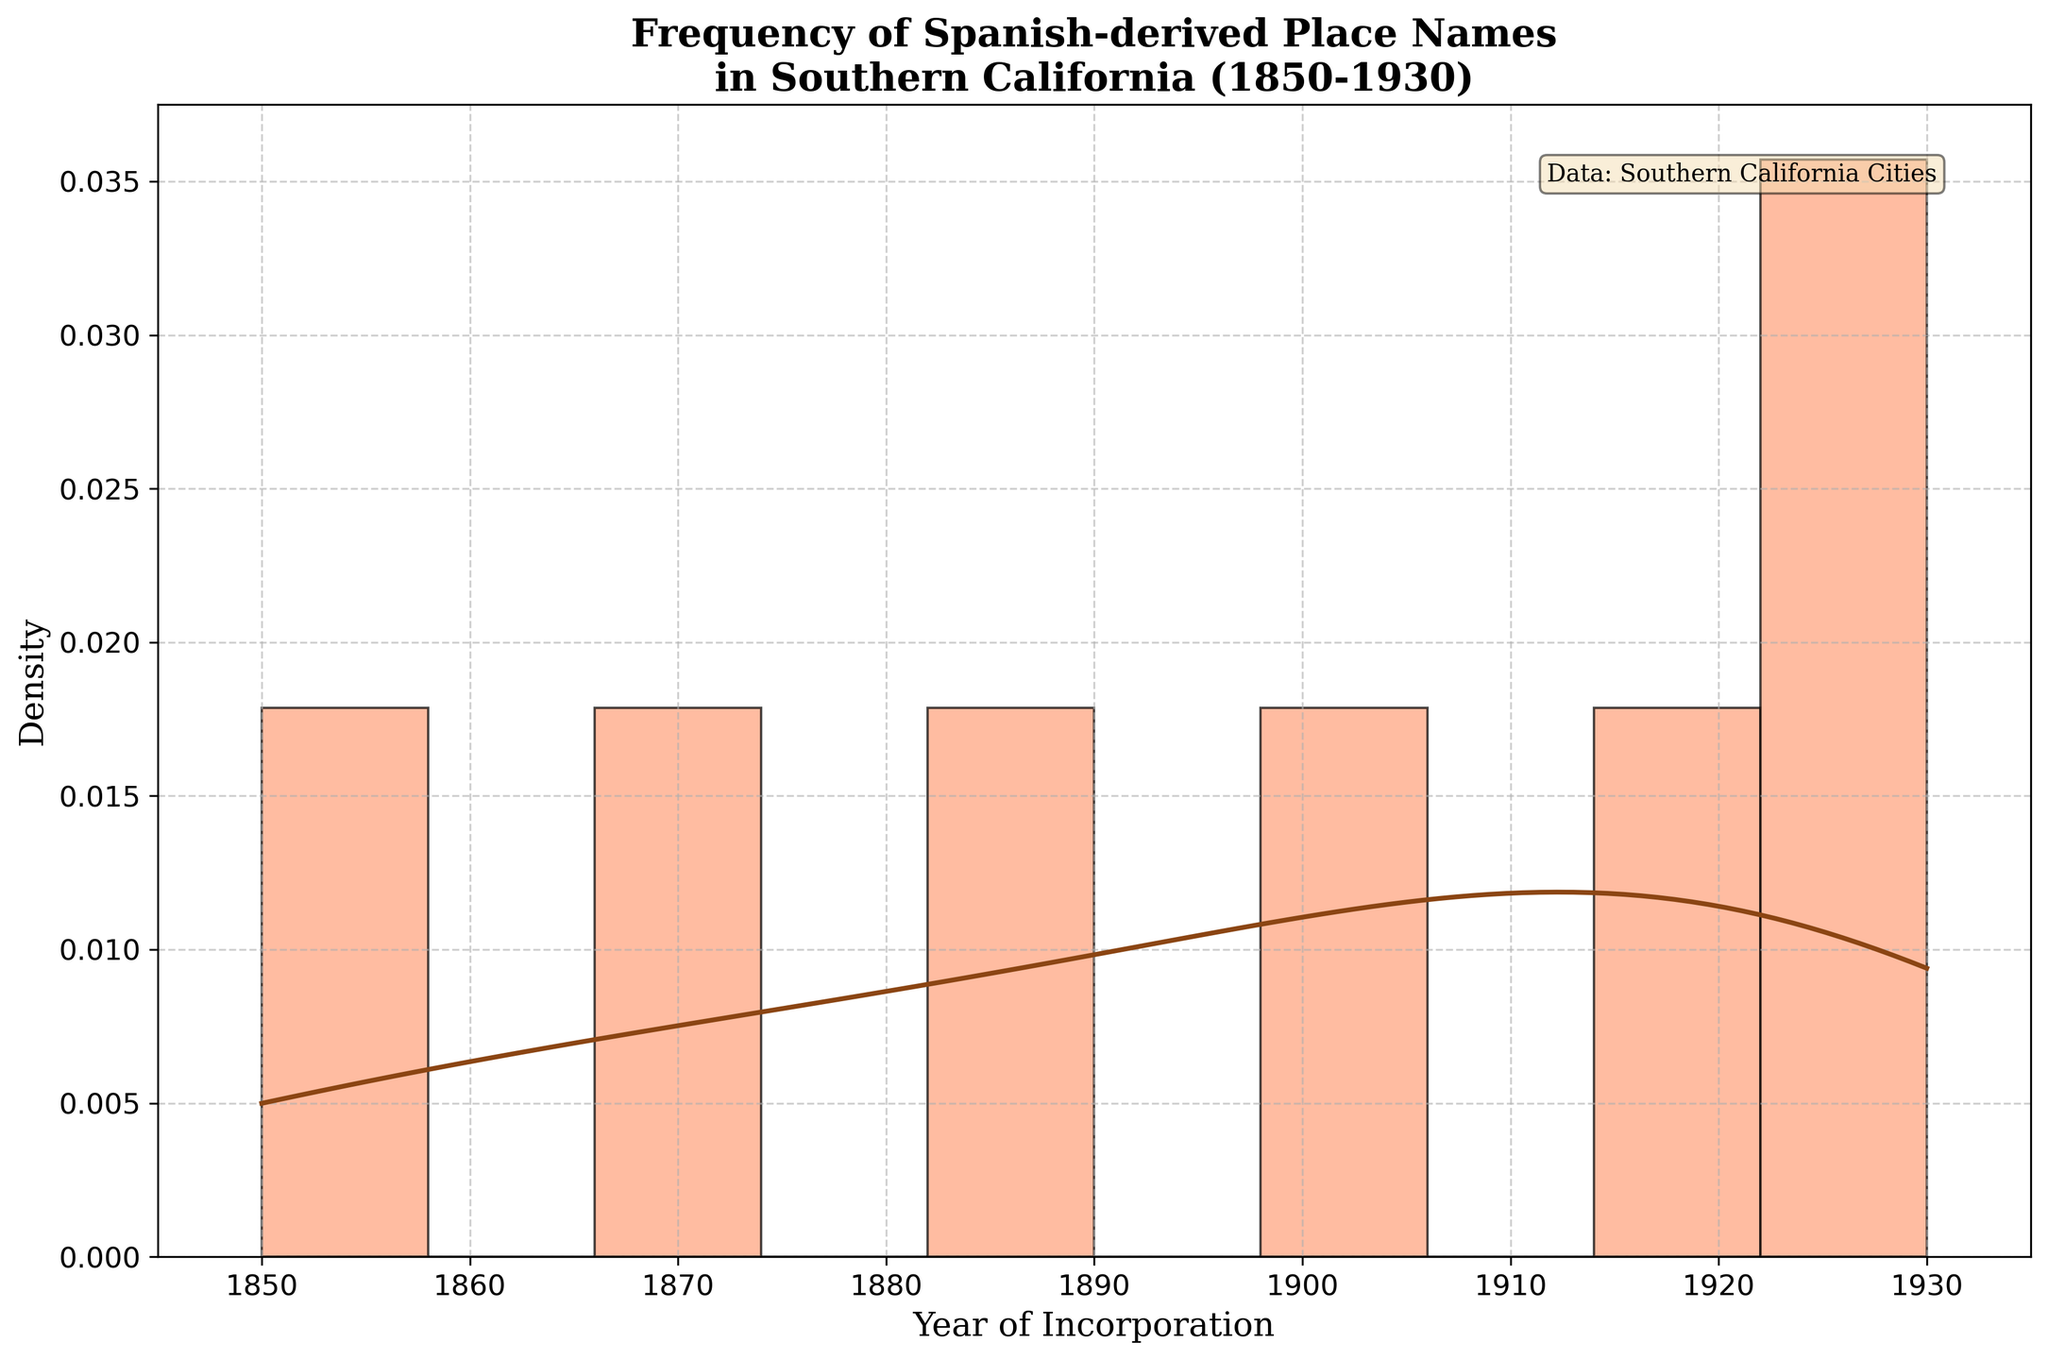What is the title of the figure? Look at the top of the figure for the title text. The title should describe the content and purpose of the figure.
Answer: Frequency of Spanish-derived Place Names in Southern California (1850-1930) What are the x and y-axis labels? Identify the text along the x-axis and y-axis, which describe what each axis represents.
Answer: Year of Incorporation, Density What color is used for the histogram bars? Determine the color of the bars in the histogram that represent the frequency of Spanish-derived place names.
Answer: Light orange Which year marks the beginning of the time range displayed on the x-axis? Refer to the far left end of the x-axis to find the year that marks the beginning of the time range.
Answer: 1845 Which year marks the end of the time range displayed on the x-axis? Refer to the far right end of the x-axis to find the year that marks the end of the time range.
Answer: 1935 In which time period (decade) does the peak density of Spanish-derived place names occur? Identify the highest point on the KDE curve and note the corresponding time period on the x-axis.
Answer: 1920s How many bins are used in the histogram? Count the individual bars (bins) displayed in the histogram. Each bin represents a specific range of years.
Answer: 10 Compare the density of Spanish-derived place names before and after 1900. Which period has a higher density? Examine the KDE curve to compare the overall density (height of the curve) of Spanish-derived place names before and after the year 1900.
Answer: After 1900 What is the time range of the largest bin? Locate the widest bar in the histogram and determine the time range it covers by looking at the x-axis extremes of that bar.
Answer: 1885-1895 At approximately which year is there a noticeable drop in the density curve? Find the point on the KDE curve where the density noticeably decreases and check the corresponding year on the x-axis.
Answer: 1920 